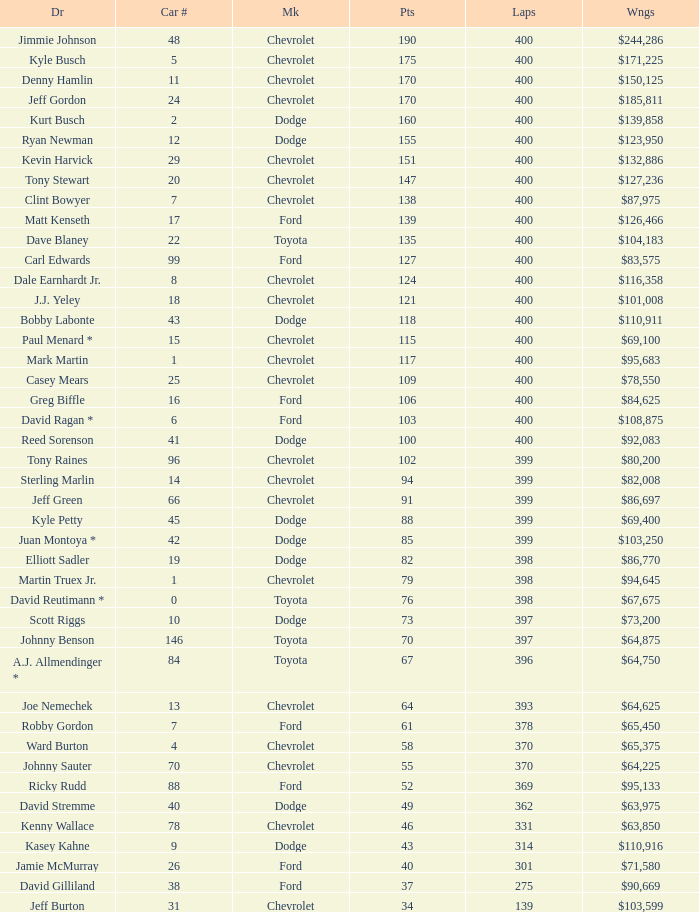What is the car number that has less than 369 laps for a Dodge with more than 49 points? None. 